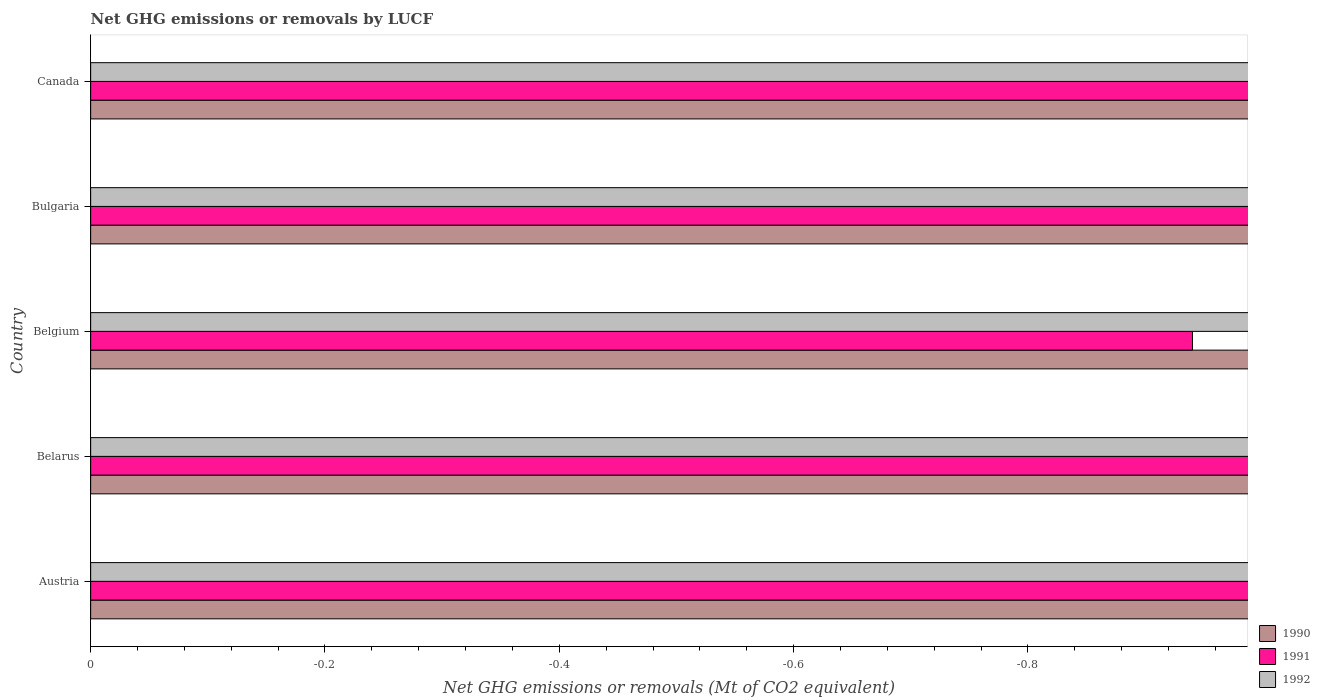Are the number of bars per tick equal to the number of legend labels?
Offer a very short reply. No. How many bars are there on the 4th tick from the top?
Provide a short and direct response. 0. In how many cases, is the number of bars for a given country not equal to the number of legend labels?
Make the answer very short. 5. What is the total net GHG emissions or removals by LUCF in 1990 in the graph?
Your answer should be compact. 0. What is the difference between the net GHG emissions or removals by LUCF in 1992 in Canada and the net GHG emissions or removals by LUCF in 1990 in Austria?
Your response must be concise. 0. What is the average net GHG emissions or removals by LUCF in 1991 per country?
Give a very brief answer. 0. In how many countries, is the net GHG emissions or removals by LUCF in 1991 greater than the average net GHG emissions or removals by LUCF in 1991 taken over all countries?
Your answer should be very brief. 0. Is it the case that in every country, the sum of the net GHG emissions or removals by LUCF in 1992 and net GHG emissions or removals by LUCF in 1990 is greater than the net GHG emissions or removals by LUCF in 1991?
Provide a short and direct response. No. Are all the bars in the graph horizontal?
Provide a short and direct response. Yes. What is the difference between two consecutive major ticks on the X-axis?
Your answer should be compact. 0.2. Are the values on the major ticks of X-axis written in scientific E-notation?
Give a very brief answer. No. Where does the legend appear in the graph?
Ensure brevity in your answer.  Bottom right. How many legend labels are there?
Offer a very short reply. 3. How are the legend labels stacked?
Offer a terse response. Vertical. What is the title of the graph?
Provide a short and direct response. Net GHG emissions or removals by LUCF. What is the label or title of the X-axis?
Provide a succinct answer. Net GHG emissions or removals (Mt of CO2 equivalent). What is the Net GHG emissions or removals (Mt of CO2 equivalent) of 1990 in Austria?
Your answer should be compact. 0. What is the Net GHG emissions or removals (Mt of CO2 equivalent) in 1991 in Austria?
Provide a short and direct response. 0. What is the Net GHG emissions or removals (Mt of CO2 equivalent) of 1991 in Belarus?
Give a very brief answer. 0. What is the Net GHG emissions or removals (Mt of CO2 equivalent) of 1990 in Belgium?
Your response must be concise. 0. What is the Net GHG emissions or removals (Mt of CO2 equivalent) in 1991 in Belgium?
Your answer should be compact. 0. What is the Net GHG emissions or removals (Mt of CO2 equivalent) in 1990 in Canada?
Ensure brevity in your answer.  0. What is the total Net GHG emissions or removals (Mt of CO2 equivalent) of 1991 in the graph?
Offer a very short reply. 0. What is the total Net GHG emissions or removals (Mt of CO2 equivalent) in 1992 in the graph?
Your answer should be very brief. 0. What is the average Net GHG emissions or removals (Mt of CO2 equivalent) in 1990 per country?
Your response must be concise. 0. What is the average Net GHG emissions or removals (Mt of CO2 equivalent) of 1992 per country?
Ensure brevity in your answer.  0. 